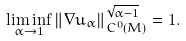Convert formula to latex. <formula><loc_0><loc_0><loc_500><loc_500>\liminf _ { \alpha \rightarrow 1 } \| \nabla u _ { \alpha } \| _ { C ^ { 0 } ( M ) } ^ { \sqrt { \alpha - 1 } } = 1 .</formula> 